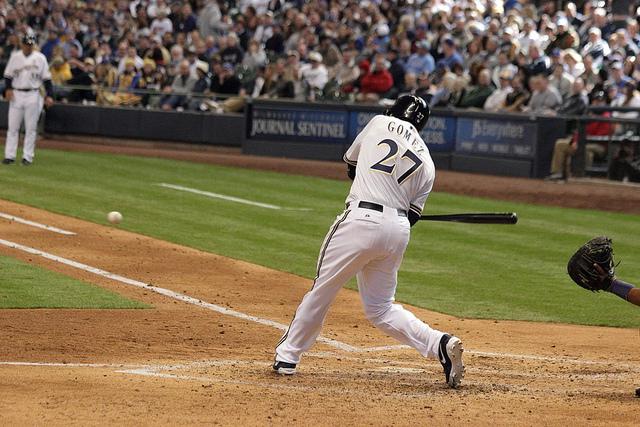What number is the batter?
Short answer required. 27. What game is the player playing?
Write a very short answer. Baseball. What is the player's number?
Give a very brief answer. 27. What is the last name of the player batting?
Quick response, please. Gomez. What is the batter's number?
Write a very short answer. 27. 